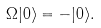Convert formula to latex. <formula><loc_0><loc_0><loc_500><loc_500>\Omega | 0 \rangle = - | 0 \rangle .</formula> 